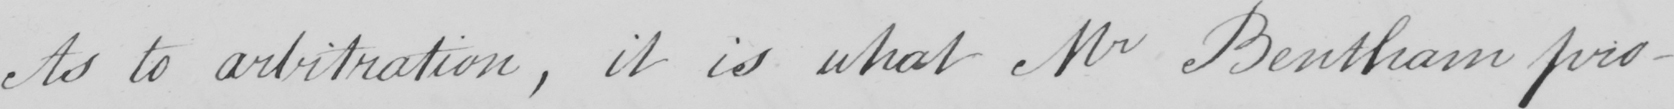What does this handwritten line say? As to arbitration , it is what Mr Bentham pro- 